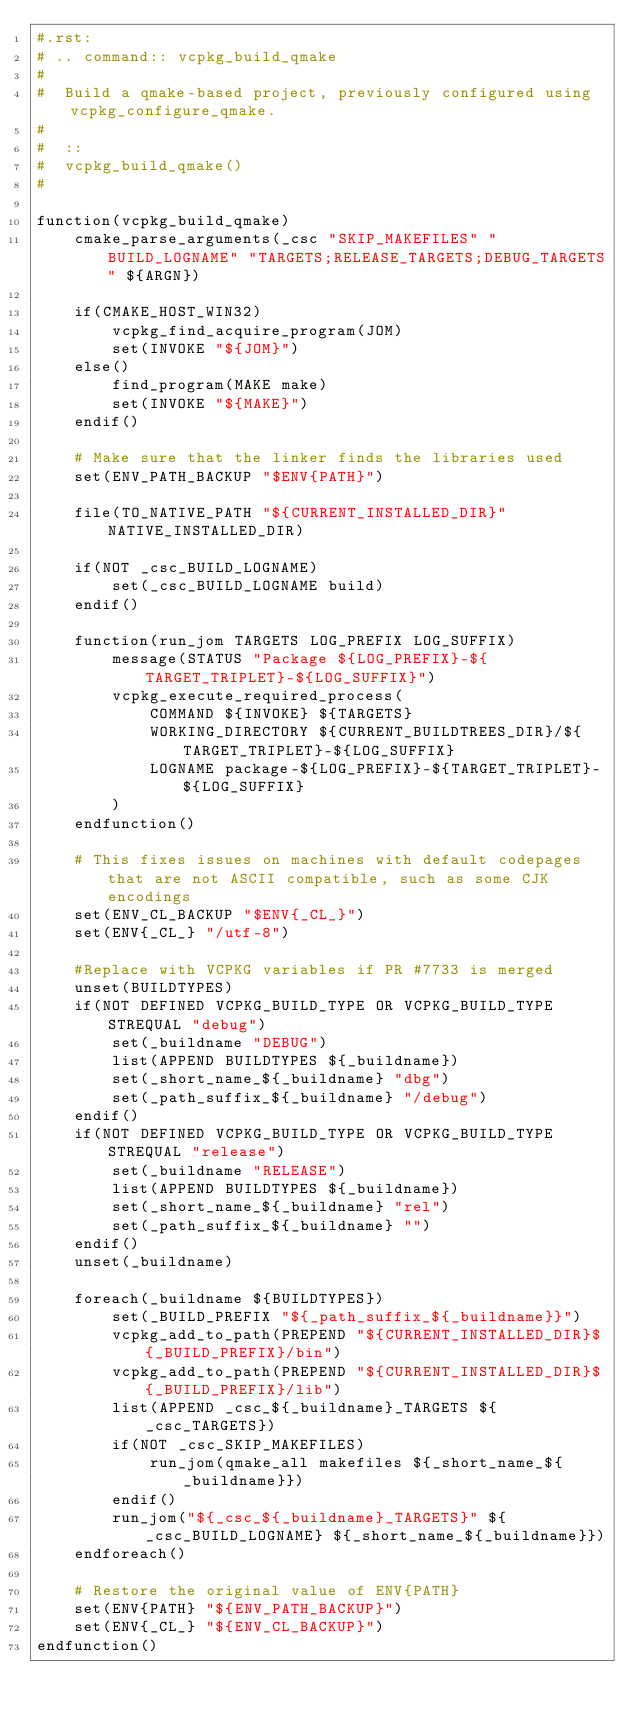Convert code to text. <code><loc_0><loc_0><loc_500><loc_500><_CMake_>#.rst:
# .. command:: vcpkg_build_qmake
#
#  Build a qmake-based project, previously configured using vcpkg_configure_qmake.
#
#  ::
#  vcpkg_build_qmake()
#

function(vcpkg_build_qmake)
    cmake_parse_arguments(_csc "SKIP_MAKEFILES" "BUILD_LOGNAME" "TARGETS;RELEASE_TARGETS;DEBUG_TARGETS" ${ARGN})

    if(CMAKE_HOST_WIN32)
        vcpkg_find_acquire_program(JOM)
        set(INVOKE "${JOM}")
    else()
        find_program(MAKE make)
        set(INVOKE "${MAKE}")
    endif()

    # Make sure that the linker finds the libraries used 
    set(ENV_PATH_BACKUP "$ENV{PATH}")
    
    file(TO_NATIVE_PATH "${CURRENT_INSTALLED_DIR}" NATIVE_INSTALLED_DIR)

    if(NOT _csc_BUILD_LOGNAME)
        set(_csc_BUILD_LOGNAME build)
    endif()

    function(run_jom TARGETS LOG_PREFIX LOG_SUFFIX)
        message(STATUS "Package ${LOG_PREFIX}-${TARGET_TRIPLET}-${LOG_SUFFIX}")
        vcpkg_execute_required_process(
            COMMAND ${INVOKE} ${TARGETS}
            WORKING_DIRECTORY ${CURRENT_BUILDTREES_DIR}/${TARGET_TRIPLET}-${LOG_SUFFIX}
            LOGNAME package-${LOG_PREFIX}-${TARGET_TRIPLET}-${LOG_SUFFIX}
        )
    endfunction()

    # This fixes issues on machines with default codepages that are not ASCII compatible, such as some CJK encodings
    set(ENV_CL_BACKUP "$ENV{_CL_}")
    set(ENV{_CL_} "/utf-8")

    #Replace with VCPKG variables if PR #7733 is merged
    unset(BUILDTYPES)
    if(NOT DEFINED VCPKG_BUILD_TYPE OR VCPKG_BUILD_TYPE STREQUAL "debug")
        set(_buildname "DEBUG")
        list(APPEND BUILDTYPES ${_buildname})
        set(_short_name_${_buildname} "dbg")
        set(_path_suffix_${_buildname} "/debug")        
    endif()
    if(NOT DEFINED VCPKG_BUILD_TYPE OR VCPKG_BUILD_TYPE STREQUAL "release")
        set(_buildname "RELEASE")
        list(APPEND BUILDTYPES ${_buildname})
        set(_short_name_${_buildname} "rel")
        set(_path_suffix_${_buildname} "")        
    endif()
    unset(_buildname)
    
    foreach(_buildname ${BUILDTYPES})
        set(_BUILD_PREFIX "${_path_suffix_${_buildname}}")
        vcpkg_add_to_path(PREPEND "${CURRENT_INSTALLED_DIR}${_BUILD_PREFIX}/bin")
        vcpkg_add_to_path(PREPEND "${CURRENT_INSTALLED_DIR}${_BUILD_PREFIX}/lib")
        list(APPEND _csc_${_buildname}_TARGETS ${_csc_TARGETS})
        if(NOT _csc_SKIP_MAKEFILES)
            run_jom(qmake_all makefiles ${_short_name_${_buildname}})
        endif()
        run_jom("${_csc_${_buildname}_TARGETS}" ${_csc_BUILD_LOGNAME} ${_short_name_${_buildname}})
    endforeach()
      
    # Restore the original value of ENV{PATH}
    set(ENV{PATH} "${ENV_PATH_BACKUP}")
    set(ENV{_CL_} "${ENV_CL_BACKUP}")
endfunction()
</code> 